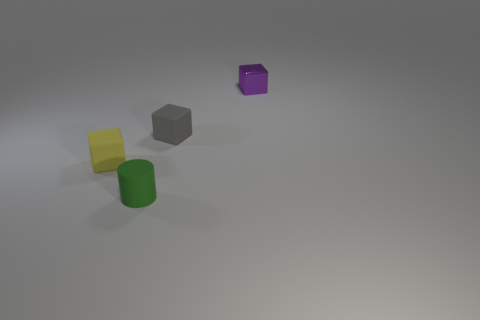There is a rubber thing that is both in front of the gray rubber cube and behind the small matte cylinder; what is its size?
Your response must be concise. Small. What is the shape of the green rubber object?
Offer a terse response. Cylinder. Are there any other things that have the same size as the purple metal block?
Keep it short and to the point. Yes. Is the number of rubber cylinders left of the small yellow cube greater than the number of shiny objects?
Your answer should be very brief. No. The metallic thing right of the tiny matte thing that is in front of the rubber block that is in front of the gray object is what shape?
Your response must be concise. Cube. There is a rubber cube that is in front of the gray matte thing; is its size the same as the purple thing?
Ensure brevity in your answer.  Yes. There is a small object that is both behind the green rubber thing and left of the small gray cube; what is its shape?
Your answer should be very brief. Cube. Do the matte cylinder and the tiny object that is to the right of the gray matte block have the same color?
Your response must be concise. No. There is a object right of the rubber object behind the rubber thing that is left of the tiny green cylinder; what is its color?
Your answer should be very brief. Purple. What color is the tiny metallic thing that is the same shape as the small yellow rubber object?
Your answer should be compact. Purple. 